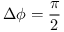<formula> <loc_0><loc_0><loc_500><loc_500>\Delta \phi = \frac { \pi } { 2 }</formula> 